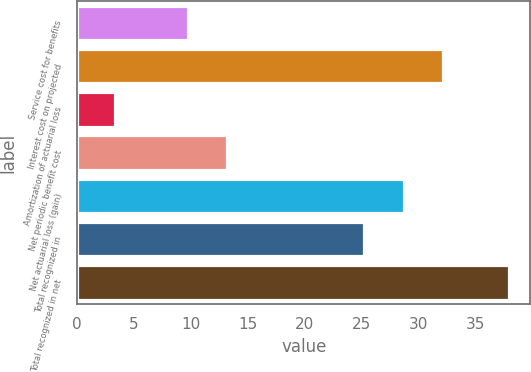Convert chart. <chart><loc_0><loc_0><loc_500><loc_500><bar_chart><fcel>Service cost for benefits<fcel>Interest cost on projected<fcel>Amortization of actuarial loss<fcel>Net periodic benefit cost<fcel>Net actuarial loss (gain)<fcel>Total recognized in<fcel>Total recognized in net<nl><fcel>9.7<fcel>32.12<fcel>3.3<fcel>13.16<fcel>28.66<fcel>25.2<fcel>37.9<nl></chart> 